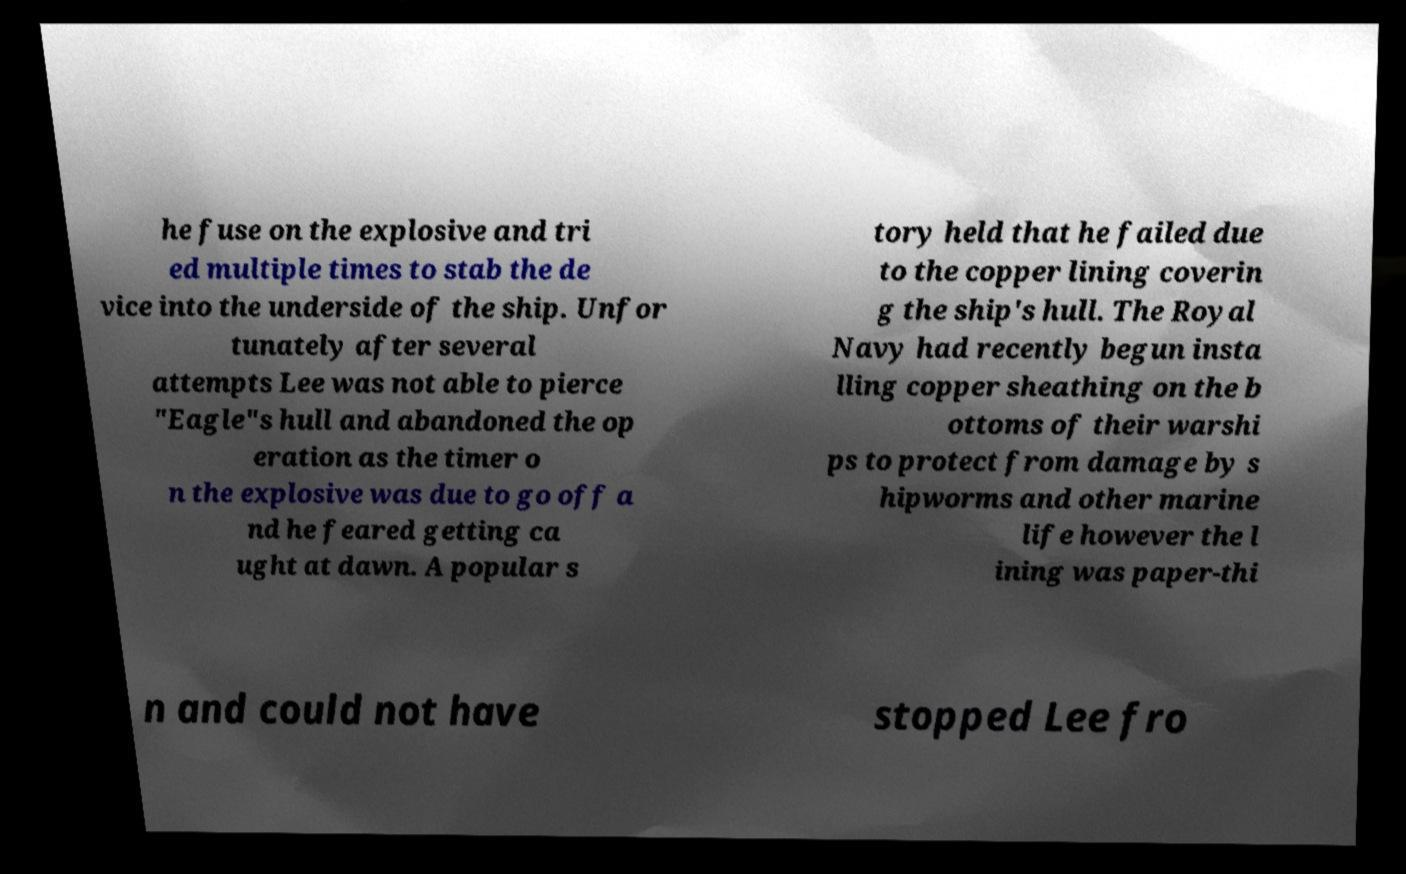Please read and relay the text visible in this image. What does it say? he fuse on the explosive and tri ed multiple times to stab the de vice into the underside of the ship. Unfor tunately after several attempts Lee was not able to pierce "Eagle"s hull and abandoned the op eration as the timer o n the explosive was due to go off a nd he feared getting ca ught at dawn. A popular s tory held that he failed due to the copper lining coverin g the ship's hull. The Royal Navy had recently begun insta lling copper sheathing on the b ottoms of their warshi ps to protect from damage by s hipworms and other marine life however the l ining was paper-thi n and could not have stopped Lee fro 